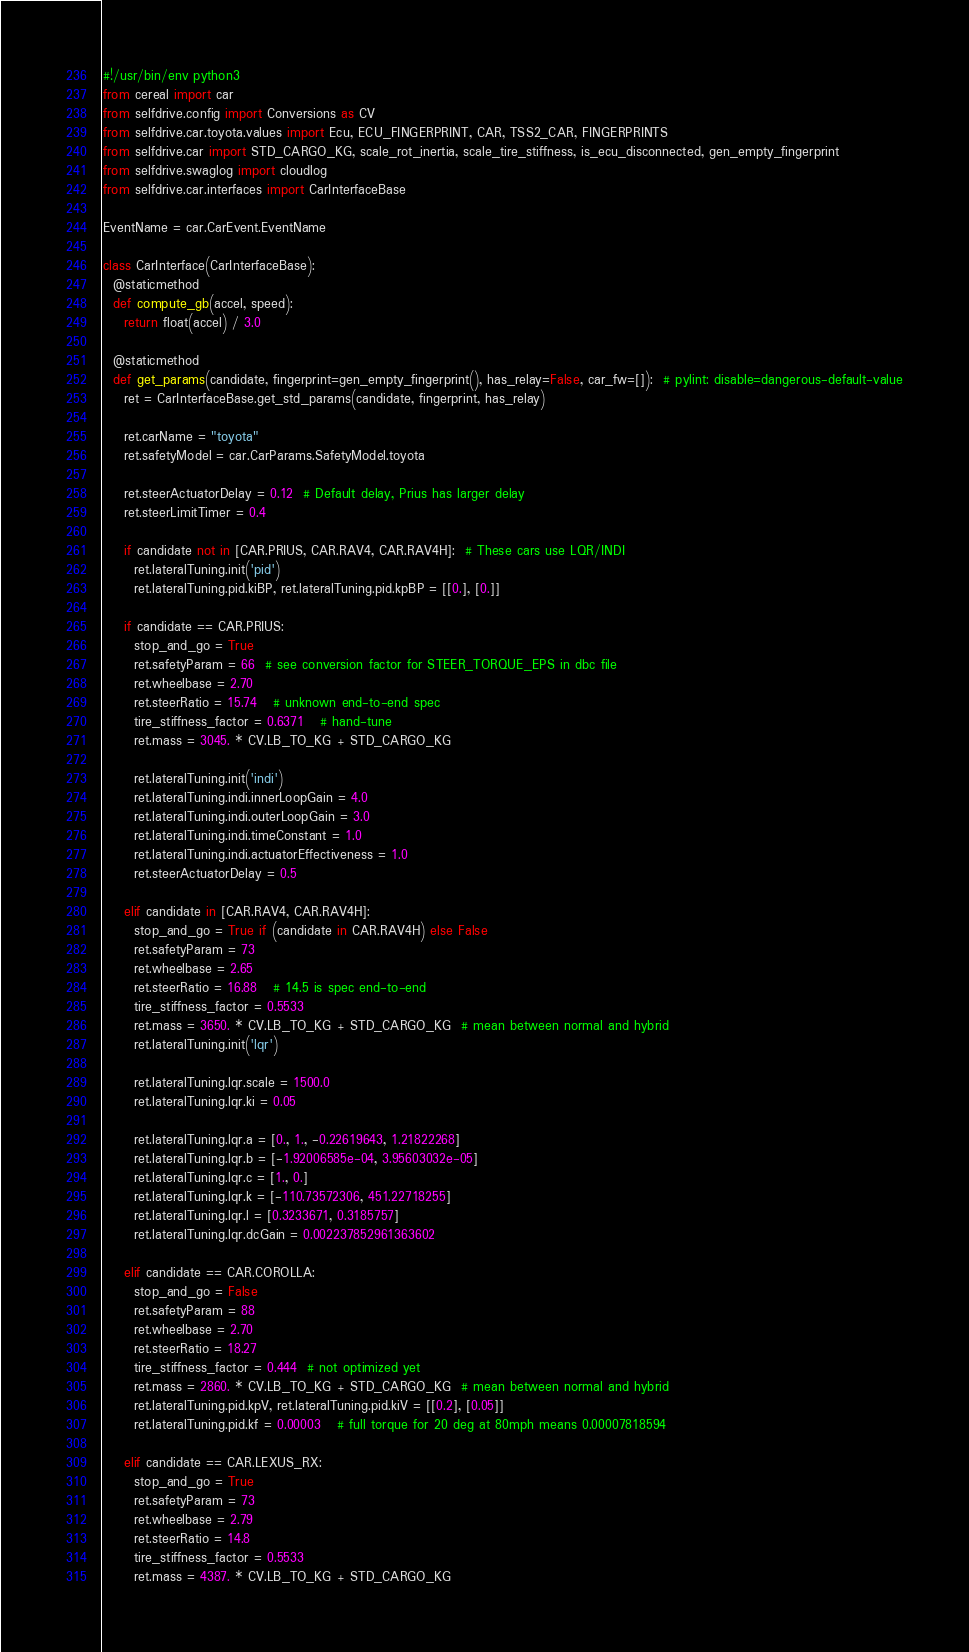Convert code to text. <code><loc_0><loc_0><loc_500><loc_500><_Python_>#!/usr/bin/env python3
from cereal import car
from selfdrive.config import Conversions as CV
from selfdrive.car.toyota.values import Ecu, ECU_FINGERPRINT, CAR, TSS2_CAR, FINGERPRINTS
from selfdrive.car import STD_CARGO_KG, scale_rot_inertia, scale_tire_stiffness, is_ecu_disconnected, gen_empty_fingerprint
from selfdrive.swaglog import cloudlog
from selfdrive.car.interfaces import CarInterfaceBase

EventName = car.CarEvent.EventName

class CarInterface(CarInterfaceBase):
  @staticmethod
  def compute_gb(accel, speed):
    return float(accel) / 3.0

  @staticmethod
  def get_params(candidate, fingerprint=gen_empty_fingerprint(), has_relay=False, car_fw=[]):  # pylint: disable=dangerous-default-value
    ret = CarInterfaceBase.get_std_params(candidate, fingerprint, has_relay)

    ret.carName = "toyota"
    ret.safetyModel = car.CarParams.SafetyModel.toyota

    ret.steerActuatorDelay = 0.12  # Default delay, Prius has larger delay
    ret.steerLimitTimer = 0.4

    if candidate not in [CAR.PRIUS, CAR.RAV4, CAR.RAV4H]:  # These cars use LQR/INDI
      ret.lateralTuning.init('pid')
      ret.lateralTuning.pid.kiBP, ret.lateralTuning.pid.kpBP = [[0.], [0.]]

    if candidate == CAR.PRIUS:
      stop_and_go = True
      ret.safetyParam = 66  # see conversion factor for STEER_TORQUE_EPS in dbc file
      ret.wheelbase = 2.70
      ret.steerRatio = 15.74   # unknown end-to-end spec
      tire_stiffness_factor = 0.6371   # hand-tune
      ret.mass = 3045. * CV.LB_TO_KG + STD_CARGO_KG

      ret.lateralTuning.init('indi')
      ret.lateralTuning.indi.innerLoopGain = 4.0
      ret.lateralTuning.indi.outerLoopGain = 3.0
      ret.lateralTuning.indi.timeConstant = 1.0
      ret.lateralTuning.indi.actuatorEffectiveness = 1.0
      ret.steerActuatorDelay = 0.5

    elif candidate in [CAR.RAV4, CAR.RAV4H]:
      stop_and_go = True if (candidate in CAR.RAV4H) else False
      ret.safetyParam = 73
      ret.wheelbase = 2.65
      ret.steerRatio = 16.88   # 14.5 is spec end-to-end
      tire_stiffness_factor = 0.5533
      ret.mass = 3650. * CV.LB_TO_KG + STD_CARGO_KG  # mean between normal and hybrid
      ret.lateralTuning.init('lqr')

      ret.lateralTuning.lqr.scale = 1500.0
      ret.lateralTuning.lqr.ki = 0.05

      ret.lateralTuning.lqr.a = [0., 1., -0.22619643, 1.21822268]
      ret.lateralTuning.lqr.b = [-1.92006585e-04, 3.95603032e-05]
      ret.lateralTuning.lqr.c = [1., 0.]
      ret.lateralTuning.lqr.k = [-110.73572306, 451.22718255]
      ret.lateralTuning.lqr.l = [0.3233671, 0.3185757]
      ret.lateralTuning.lqr.dcGain = 0.002237852961363602

    elif candidate == CAR.COROLLA:
      stop_and_go = False
      ret.safetyParam = 88
      ret.wheelbase = 2.70
      ret.steerRatio = 18.27
      tire_stiffness_factor = 0.444  # not optimized yet
      ret.mass = 2860. * CV.LB_TO_KG + STD_CARGO_KG  # mean between normal and hybrid
      ret.lateralTuning.pid.kpV, ret.lateralTuning.pid.kiV = [[0.2], [0.05]]
      ret.lateralTuning.pid.kf = 0.00003   # full torque for 20 deg at 80mph means 0.00007818594

    elif candidate == CAR.LEXUS_RX:
      stop_and_go = True
      ret.safetyParam = 73
      ret.wheelbase = 2.79
      ret.steerRatio = 14.8
      tire_stiffness_factor = 0.5533
      ret.mass = 4387. * CV.LB_TO_KG + STD_CARGO_KG</code> 